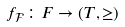<formula> <loc_0><loc_0><loc_500><loc_500>f _ { \mathcal { F } } \colon F \to ( T , \geq )</formula> 